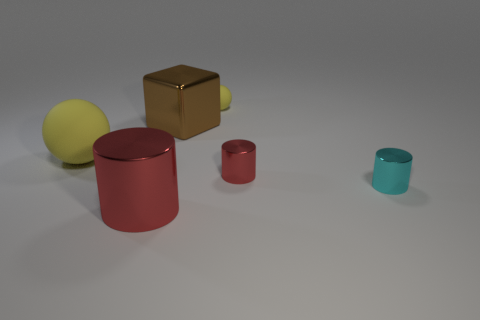Add 1 small red cylinders. How many objects exist? 7 Subtract all cubes. How many objects are left? 5 Add 4 tiny yellow matte spheres. How many tiny yellow matte spheres exist? 5 Subtract 2 yellow spheres. How many objects are left? 4 Subtract all big blue matte cubes. Subtract all tiny red things. How many objects are left? 5 Add 3 large red metallic objects. How many large red metallic objects are left? 4 